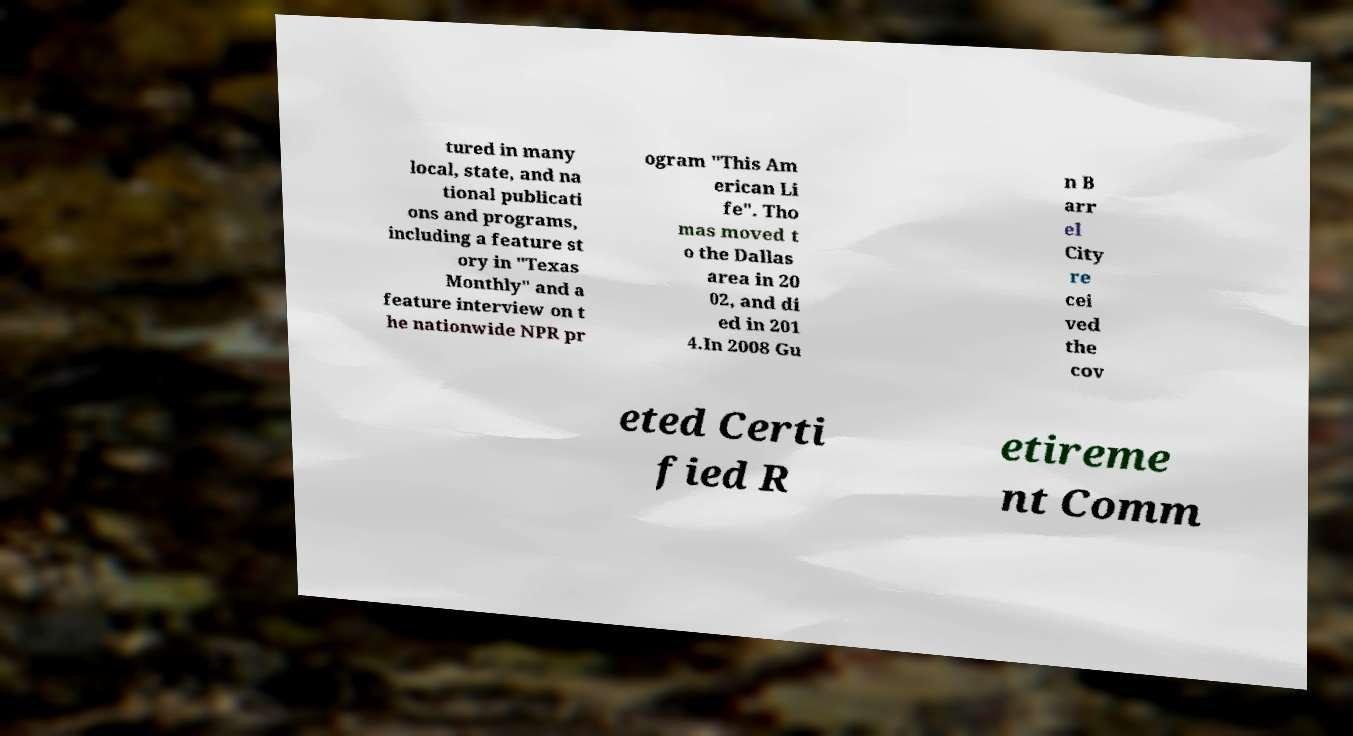Please identify and transcribe the text found in this image. tured in many local, state, and na tional publicati ons and programs, including a feature st ory in "Texas Monthly" and a feature interview on t he nationwide NPR pr ogram "This Am erican Li fe". Tho mas moved t o the Dallas area in 20 02, and di ed in 201 4.In 2008 Gu n B arr el City re cei ved the cov eted Certi fied R etireme nt Comm 